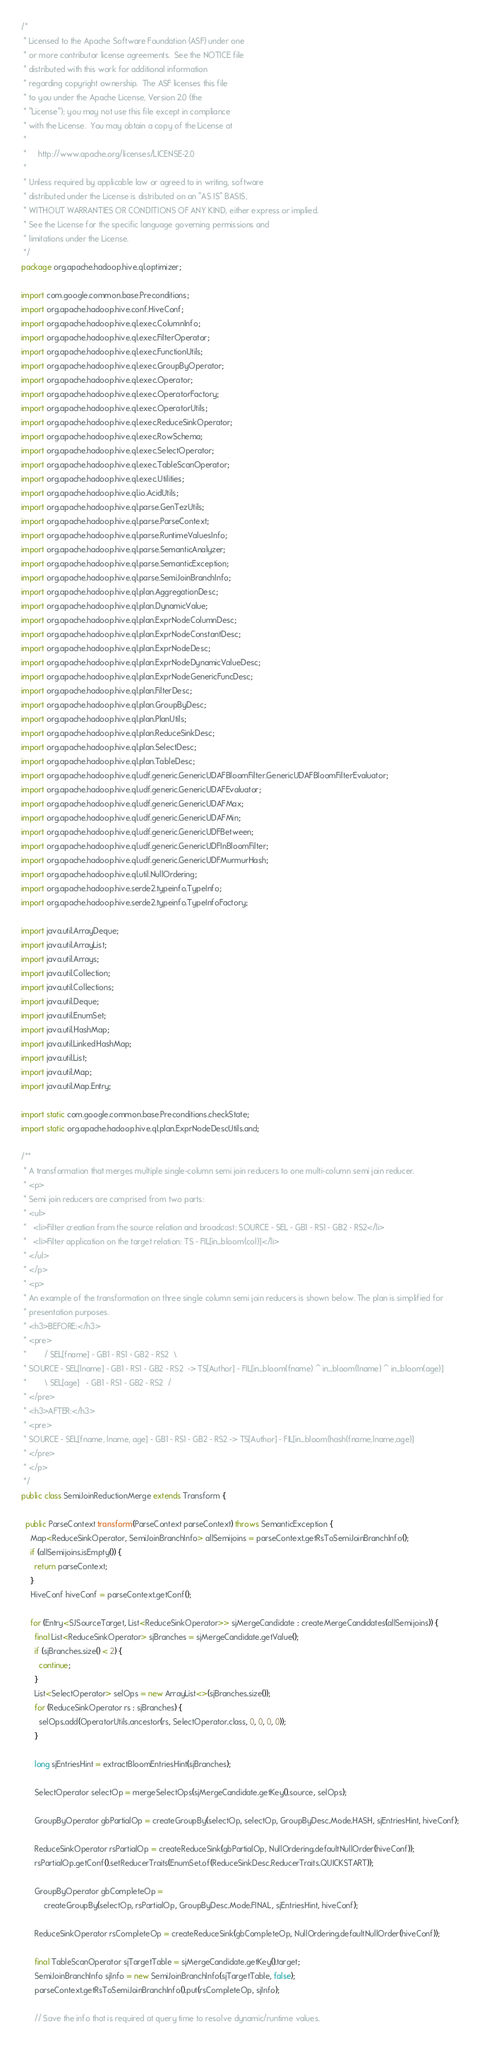<code> <loc_0><loc_0><loc_500><loc_500><_Java_>/*
 * Licensed to the Apache Software Foundation (ASF) under one
 * or more contributor license agreements.  See the NOTICE file
 * distributed with this work for additional information
 * regarding copyright ownership.  The ASF licenses this file
 * to you under the Apache License, Version 2.0 (the
 * "License"); you may not use this file except in compliance
 * with the License.  You may obtain a copy of the License at
 *
 *     http://www.apache.org/licenses/LICENSE-2.0
 *
 * Unless required by applicable law or agreed to in writing, software
 * distributed under the License is distributed on an "AS IS" BASIS,
 * WITHOUT WARRANTIES OR CONDITIONS OF ANY KIND, either express or implied.
 * See the License for the specific language governing permissions and
 * limitations under the License.
 */
package org.apache.hadoop.hive.ql.optimizer;

import com.google.common.base.Preconditions;
import org.apache.hadoop.hive.conf.HiveConf;
import org.apache.hadoop.hive.ql.exec.ColumnInfo;
import org.apache.hadoop.hive.ql.exec.FilterOperator;
import org.apache.hadoop.hive.ql.exec.FunctionUtils;
import org.apache.hadoop.hive.ql.exec.GroupByOperator;
import org.apache.hadoop.hive.ql.exec.Operator;
import org.apache.hadoop.hive.ql.exec.OperatorFactory;
import org.apache.hadoop.hive.ql.exec.OperatorUtils;
import org.apache.hadoop.hive.ql.exec.ReduceSinkOperator;
import org.apache.hadoop.hive.ql.exec.RowSchema;
import org.apache.hadoop.hive.ql.exec.SelectOperator;
import org.apache.hadoop.hive.ql.exec.TableScanOperator;
import org.apache.hadoop.hive.ql.exec.Utilities;
import org.apache.hadoop.hive.ql.io.AcidUtils;
import org.apache.hadoop.hive.ql.parse.GenTezUtils;
import org.apache.hadoop.hive.ql.parse.ParseContext;
import org.apache.hadoop.hive.ql.parse.RuntimeValuesInfo;
import org.apache.hadoop.hive.ql.parse.SemanticAnalyzer;
import org.apache.hadoop.hive.ql.parse.SemanticException;
import org.apache.hadoop.hive.ql.parse.SemiJoinBranchInfo;
import org.apache.hadoop.hive.ql.plan.AggregationDesc;
import org.apache.hadoop.hive.ql.plan.DynamicValue;
import org.apache.hadoop.hive.ql.plan.ExprNodeColumnDesc;
import org.apache.hadoop.hive.ql.plan.ExprNodeConstantDesc;
import org.apache.hadoop.hive.ql.plan.ExprNodeDesc;
import org.apache.hadoop.hive.ql.plan.ExprNodeDynamicValueDesc;
import org.apache.hadoop.hive.ql.plan.ExprNodeGenericFuncDesc;
import org.apache.hadoop.hive.ql.plan.FilterDesc;
import org.apache.hadoop.hive.ql.plan.GroupByDesc;
import org.apache.hadoop.hive.ql.plan.PlanUtils;
import org.apache.hadoop.hive.ql.plan.ReduceSinkDesc;
import org.apache.hadoop.hive.ql.plan.SelectDesc;
import org.apache.hadoop.hive.ql.plan.TableDesc;
import org.apache.hadoop.hive.ql.udf.generic.GenericUDAFBloomFilter.GenericUDAFBloomFilterEvaluator;
import org.apache.hadoop.hive.ql.udf.generic.GenericUDAFEvaluator;
import org.apache.hadoop.hive.ql.udf.generic.GenericUDAFMax;
import org.apache.hadoop.hive.ql.udf.generic.GenericUDAFMin;
import org.apache.hadoop.hive.ql.udf.generic.GenericUDFBetween;
import org.apache.hadoop.hive.ql.udf.generic.GenericUDFInBloomFilter;
import org.apache.hadoop.hive.ql.udf.generic.GenericUDFMurmurHash;
import org.apache.hadoop.hive.ql.util.NullOrdering;
import org.apache.hadoop.hive.serde2.typeinfo.TypeInfo;
import org.apache.hadoop.hive.serde2.typeinfo.TypeInfoFactory;

import java.util.ArrayDeque;
import java.util.ArrayList;
import java.util.Arrays;
import java.util.Collection;
import java.util.Collections;
import java.util.Deque;
import java.util.EnumSet;
import java.util.HashMap;
import java.util.LinkedHashMap;
import java.util.List;
import java.util.Map;
import java.util.Map.Entry;

import static com.google.common.base.Preconditions.checkState;
import static org.apache.hadoop.hive.ql.plan.ExprNodeDescUtils.and;

/**
 * A transformation that merges multiple single-column semi join reducers to one multi-column semi join reducer.
 * <p>
 * Semi join reducers are comprised from two parts:
 * <ul>
 *   <li>Filter creation from the source relation and broadcast: SOURCE - SEL - GB1 - RS1 - GB2 - RS2</li>
 *   <li>Filter application on the target relation: TS - FIL[in_bloom(col)]</li>
 * </ul>
 * </p>
 * <p>
 * An example of the transformation on three single column semi join reducers is shown below. The plan is simplified for
 * presentation purposes.
 * <h3>BEFORE:</h3>
 * <pre>
 *        / SEL[fname] - GB1 - RS1 - GB2 - RS2  \
 * SOURCE - SEL[lname] - GB1 - RS1 - GB2 - RS2  -> TS[Author] - FIL[in_bloom(fname) ^ in_bloom(lname) ^ in_bloom(age)]
 *        \ SEL[age]   - GB1 - RS1 - GB2 - RS2  /
 * </pre>
 * <h3>AFTER:</h3>
 * <pre>
 * SOURCE - SEL[fname, lname, age] - GB1 - RS1 - GB2 - RS2 -> TS[Author] - FIL[in_bloom(hash(fname,lname,age)]
 * </pre>
 * </p>
 */
public class SemiJoinReductionMerge extends Transform {

  public ParseContext transform(ParseContext parseContext) throws SemanticException {
    Map<ReduceSinkOperator, SemiJoinBranchInfo> allSemijoins = parseContext.getRsToSemiJoinBranchInfo();
    if (allSemijoins.isEmpty()) {
      return parseContext;
    }
    HiveConf hiveConf = parseContext.getConf();

    for (Entry<SJSourceTarget, List<ReduceSinkOperator>> sjMergeCandidate : createMergeCandidates(allSemijoins)) {
      final List<ReduceSinkOperator> sjBranches = sjMergeCandidate.getValue();
      if (sjBranches.size() < 2) {
        continue;
      }
      List<SelectOperator> selOps = new ArrayList<>(sjBranches.size());
      for (ReduceSinkOperator rs : sjBranches) {
        selOps.add(OperatorUtils.ancestor(rs, SelectOperator.class, 0, 0, 0, 0));
      }

      long sjEntriesHint = extractBloomEntriesHint(sjBranches);

      SelectOperator selectOp = mergeSelectOps(sjMergeCandidate.getKey().source, selOps);

      GroupByOperator gbPartialOp = createGroupBy(selectOp, selectOp, GroupByDesc.Mode.HASH, sjEntriesHint, hiveConf);

      ReduceSinkOperator rsPartialOp = createReduceSink(gbPartialOp, NullOrdering.defaultNullOrder(hiveConf));
      rsPartialOp.getConf().setReducerTraits(EnumSet.of(ReduceSinkDesc.ReducerTraits.QUICKSTART));

      GroupByOperator gbCompleteOp =
          createGroupBy(selectOp, rsPartialOp, GroupByDesc.Mode.FINAL, sjEntriesHint, hiveConf);

      ReduceSinkOperator rsCompleteOp = createReduceSink(gbCompleteOp, NullOrdering.defaultNullOrder(hiveConf));

      final TableScanOperator sjTargetTable = sjMergeCandidate.getKey().target;
      SemiJoinBranchInfo sjInfo = new SemiJoinBranchInfo(sjTargetTable, false);
      parseContext.getRsToSemiJoinBranchInfo().put(rsCompleteOp, sjInfo);

      // Save the info that is required at query time to resolve dynamic/runtime values.</code> 